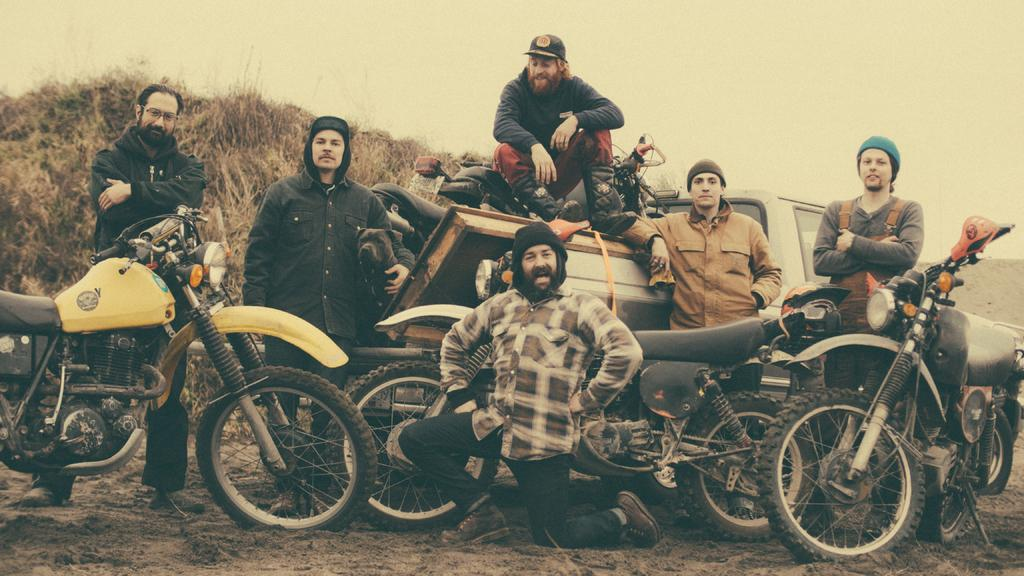How many men are in the image? There are men in the image, but the exact number is not specified. What is one man doing in the image? One man is sitting on a truck. What type of vehicles are present in the image besides the truck? There are motorbikes in the image. What else can be seen in the background of the image? There is a van and bushes in the background of the image. What is visible at the top of the image? The sky is visible in the background of the image. What type of apple is being used to cause trouble in the image? There is no apple present in the image, nor is there any indication of trouble or conflict. 